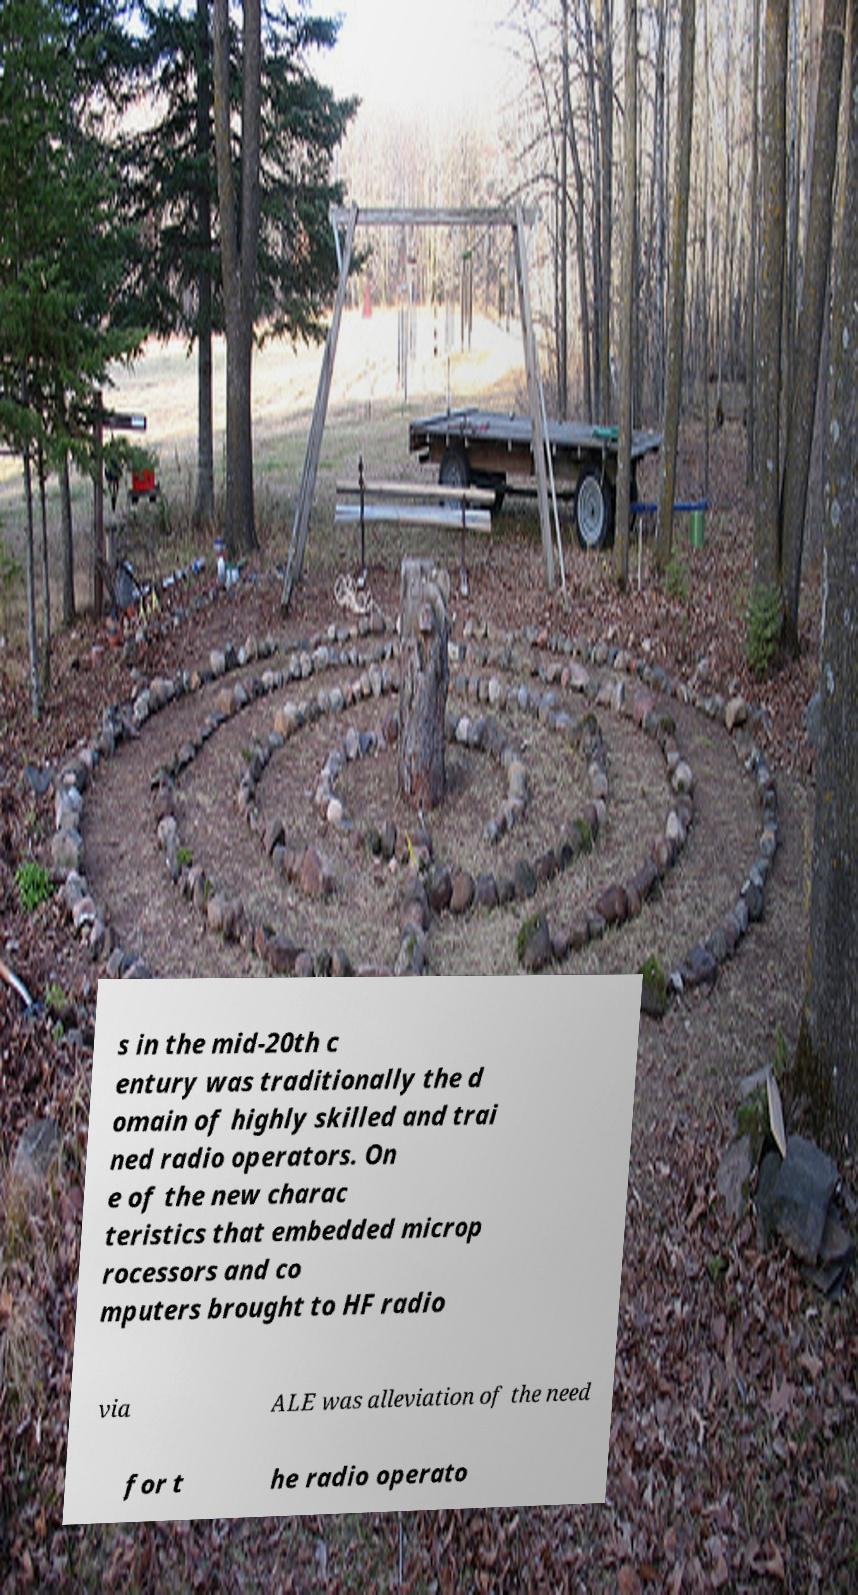Can you read and provide the text displayed in the image?This photo seems to have some interesting text. Can you extract and type it out for me? s in the mid-20th c entury was traditionally the d omain of highly skilled and trai ned radio operators. On e of the new charac teristics that embedded microp rocessors and co mputers brought to HF radio via ALE was alleviation of the need for t he radio operato 